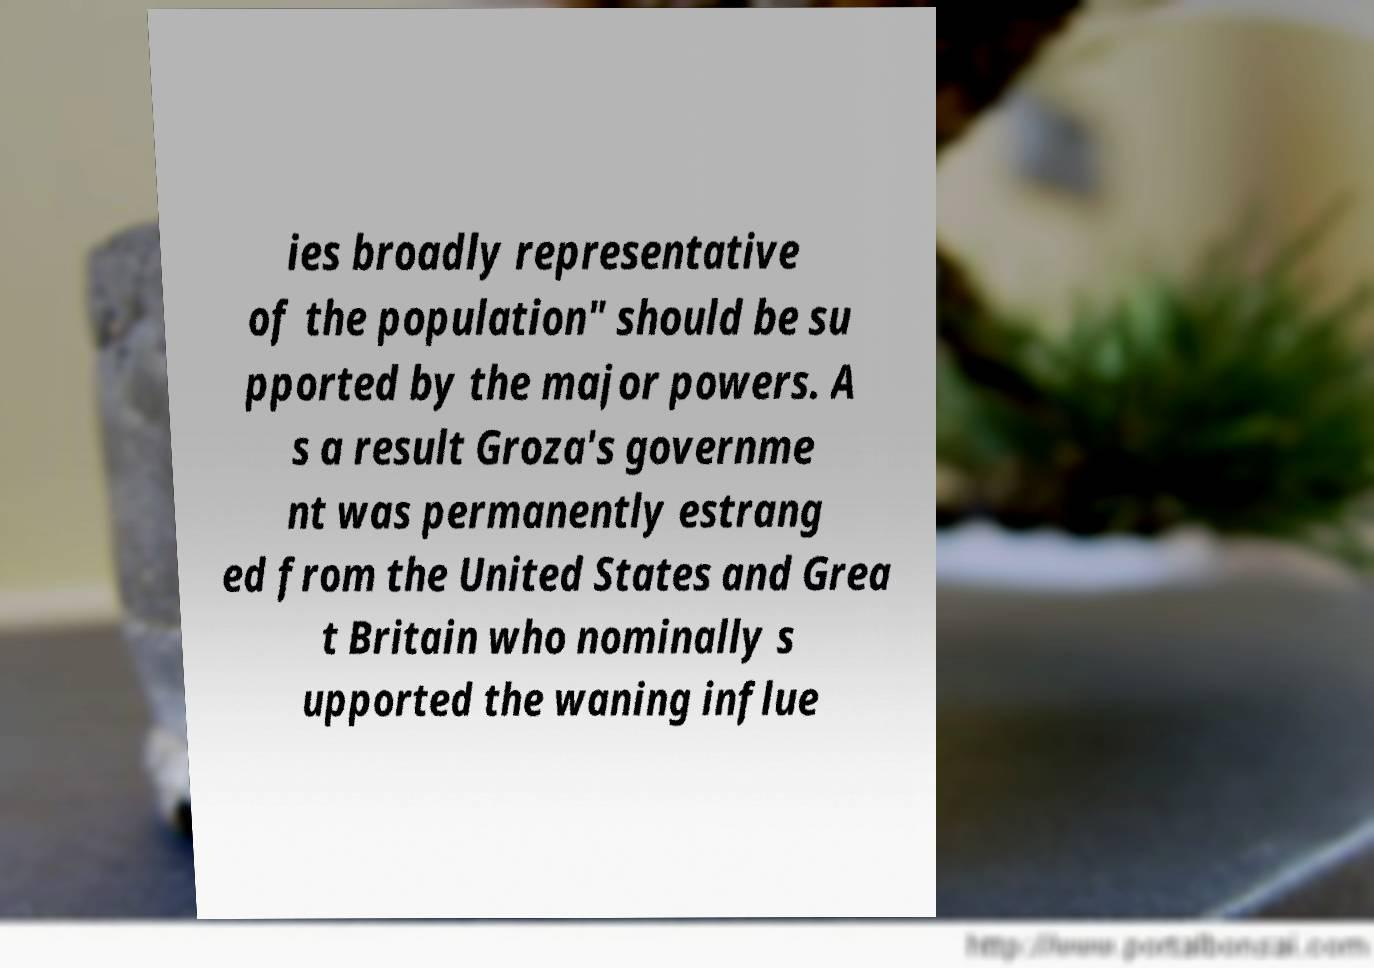What messages or text are displayed in this image? I need them in a readable, typed format. ies broadly representative of the population" should be su pported by the major powers. A s a result Groza's governme nt was permanently estrang ed from the United States and Grea t Britain who nominally s upported the waning influe 